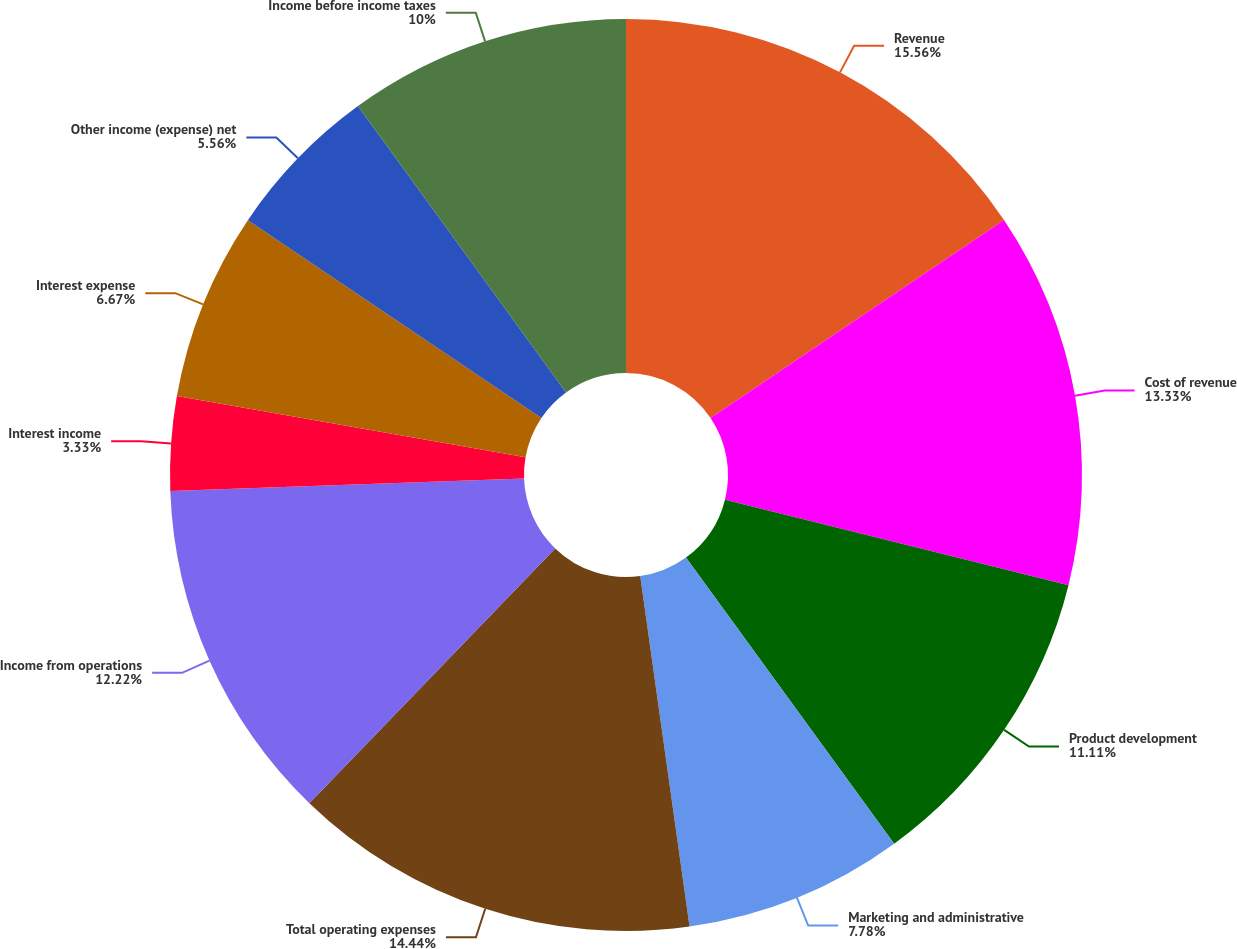Convert chart to OTSL. <chart><loc_0><loc_0><loc_500><loc_500><pie_chart><fcel>Revenue<fcel>Cost of revenue<fcel>Product development<fcel>Marketing and administrative<fcel>Total operating expenses<fcel>Income from operations<fcel>Interest income<fcel>Interest expense<fcel>Other income (expense) net<fcel>Income before income taxes<nl><fcel>15.55%<fcel>13.33%<fcel>11.11%<fcel>7.78%<fcel>14.44%<fcel>12.22%<fcel>3.33%<fcel>6.67%<fcel>5.56%<fcel>10.0%<nl></chart> 